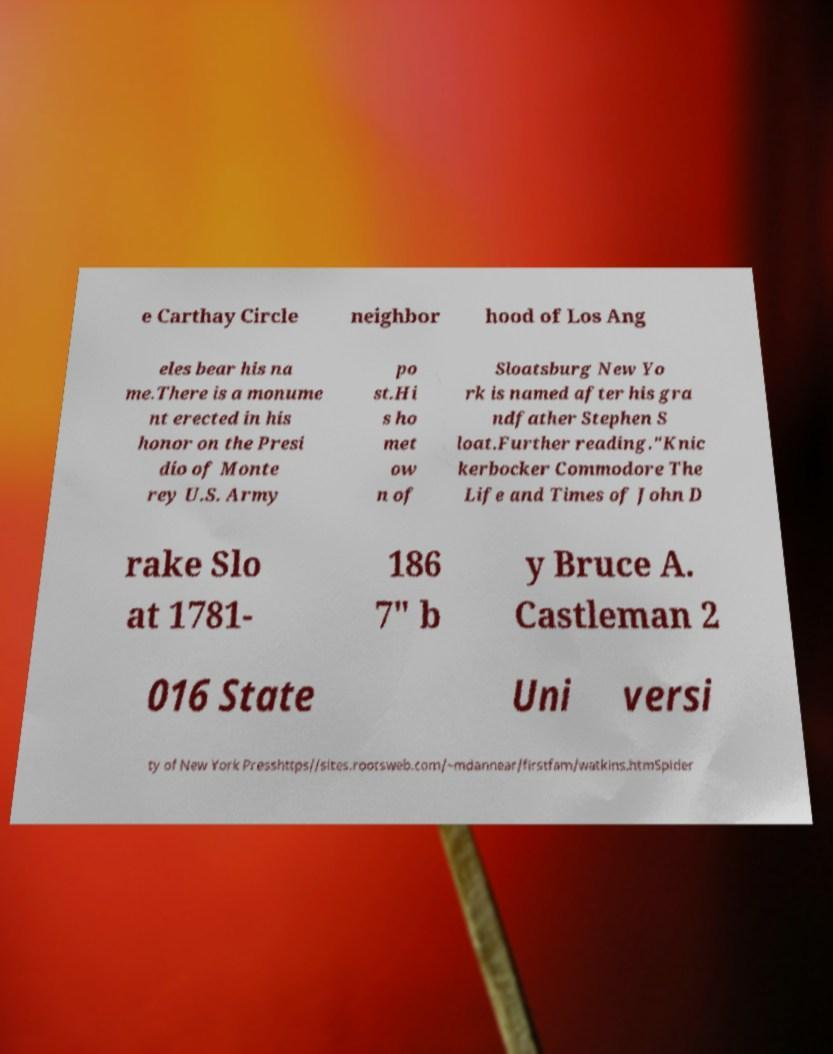Please identify and transcribe the text found in this image. e Carthay Circle neighbor hood of Los Ang eles bear his na me.There is a monume nt erected in his honor on the Presi dio of Monte rey U.S. Army po st.Hi s ho met ow n of Sloatsburg New Yo rk is named after his gra ndfather Stephen S loat.Further reading."Knic kerbocker Commodore The Life and Times of John D rake Slo at 1781- 186 7" b y Bruce A. Castleman 2 016 State Uni versi ty of New York Presshttps//sites.rootsweb.com/~mdannear/firstfam/watkins.htmSpider 